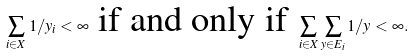<formula> <loc_0><loc_0><loc_500><loc_500>\sum _ { i \in X } 1 / y _ { i } < \infty \text { if and only if } \sum _ { i \in X } \sum _ { y \in E _ { i } } 1 / y < \infty .</formula> 